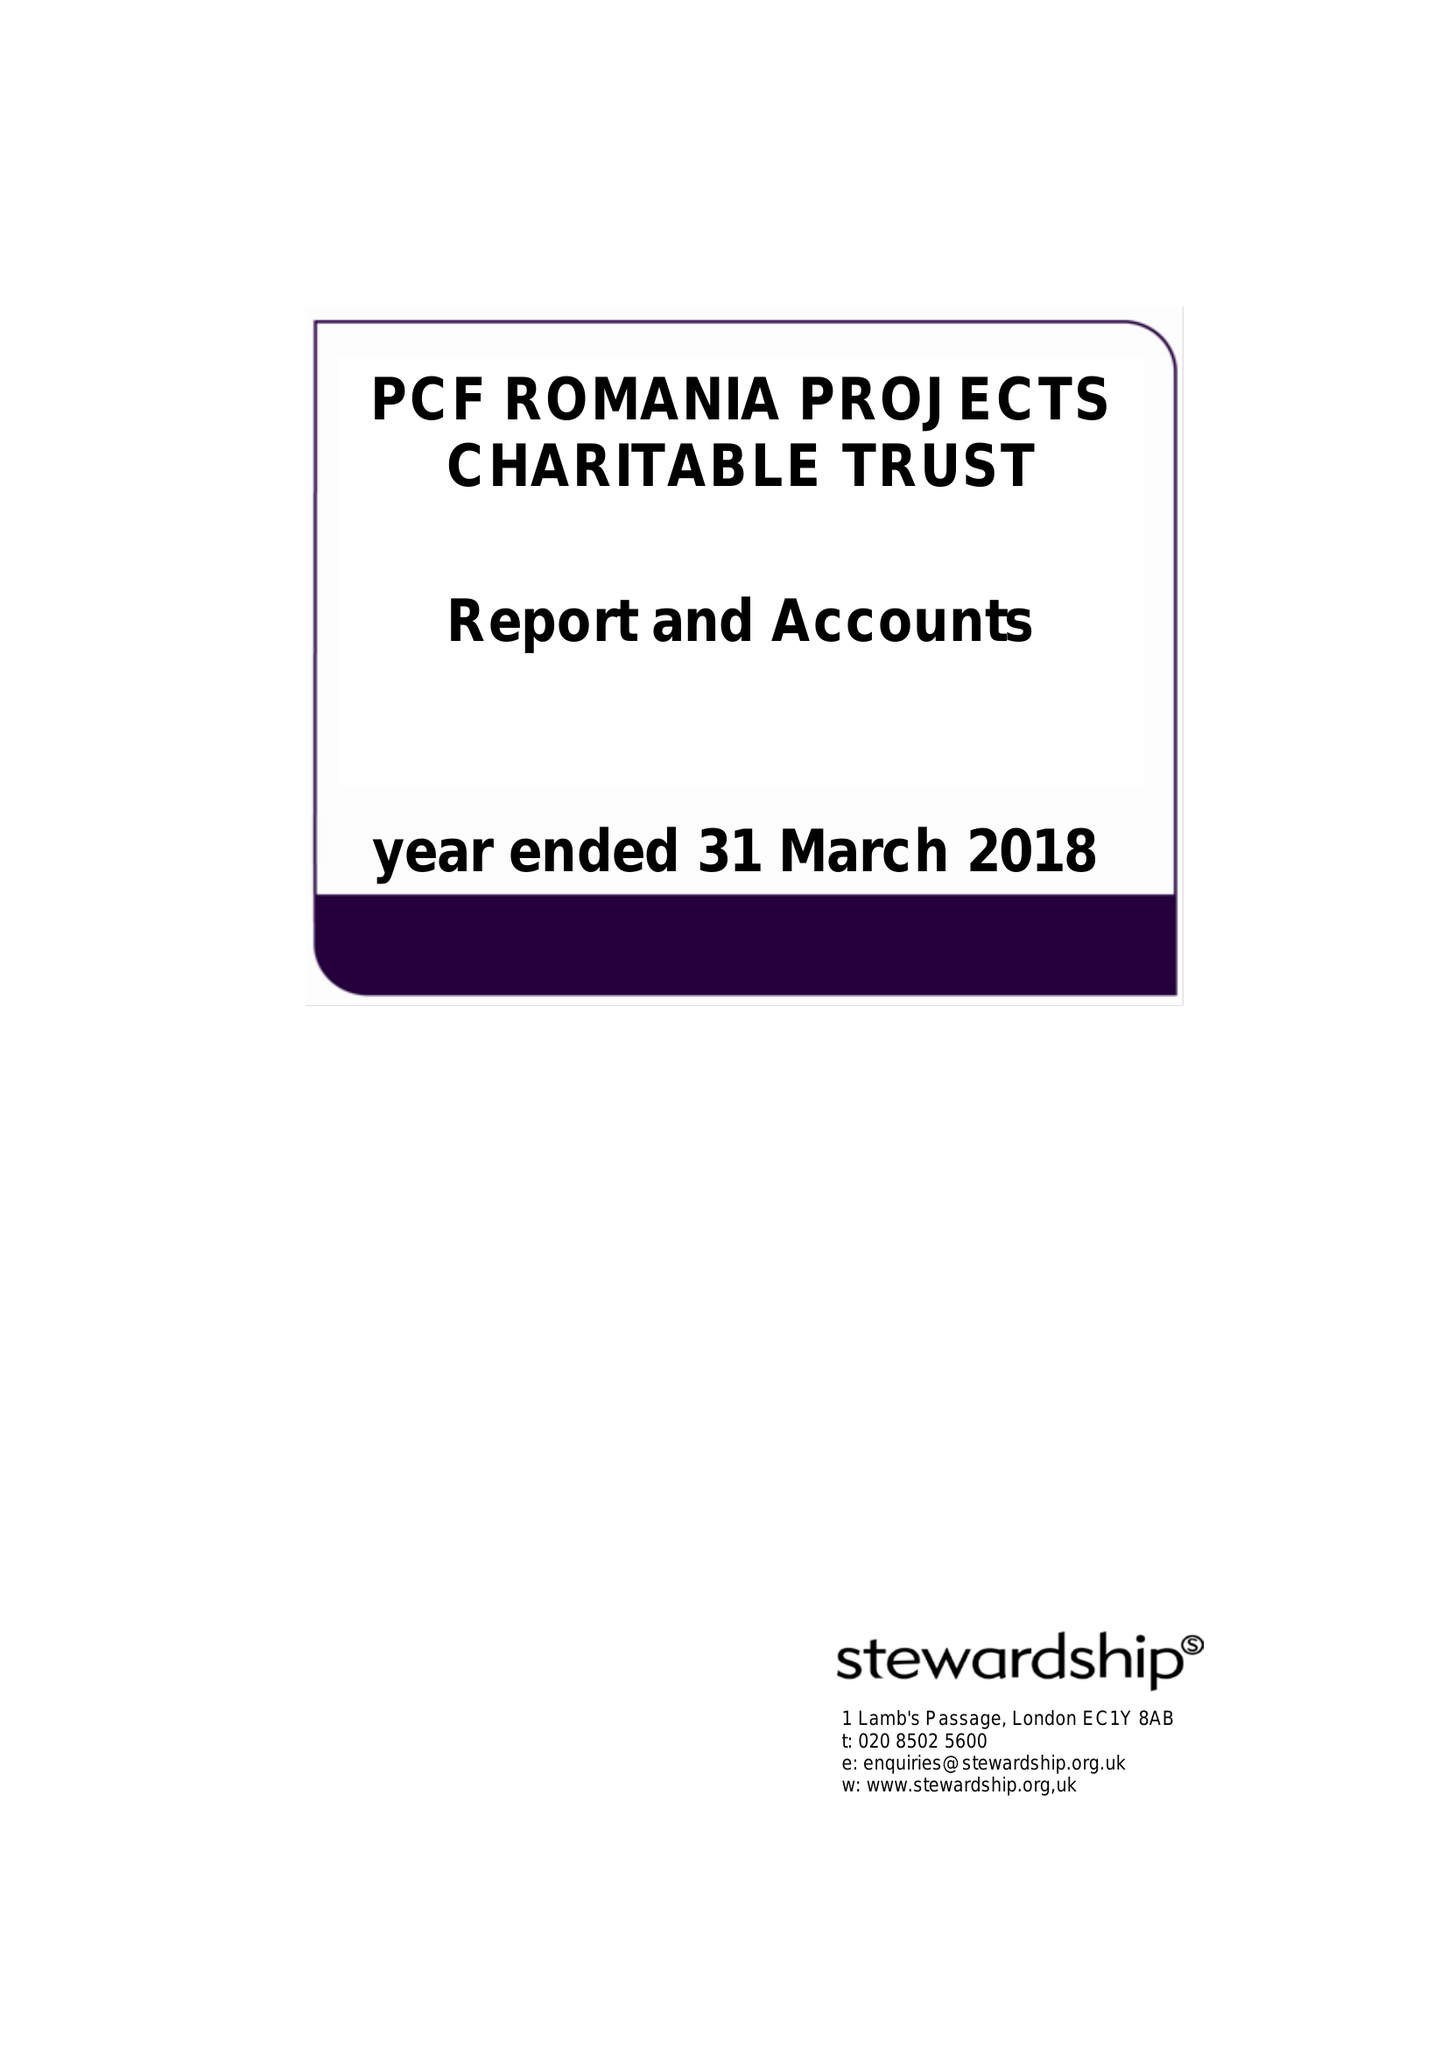What is the value for the charity_name?
Answer the question using a single word or phrase. Pcf Romania Projects Charitable Trust 